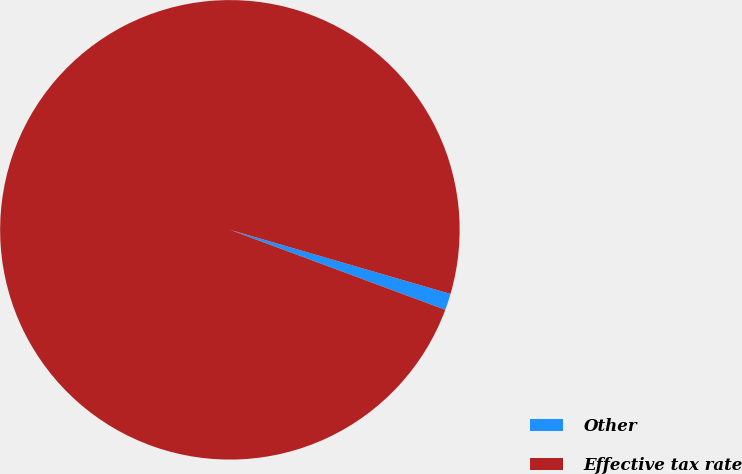Convert chart to OTSL. <chart><loc_0><loc_0><loc_500><loc_500><pie_chart><fcel>Other<fcel>Effective tax rate<nl><fcel>1.16%<fcel>98.84%<nl></chart> 